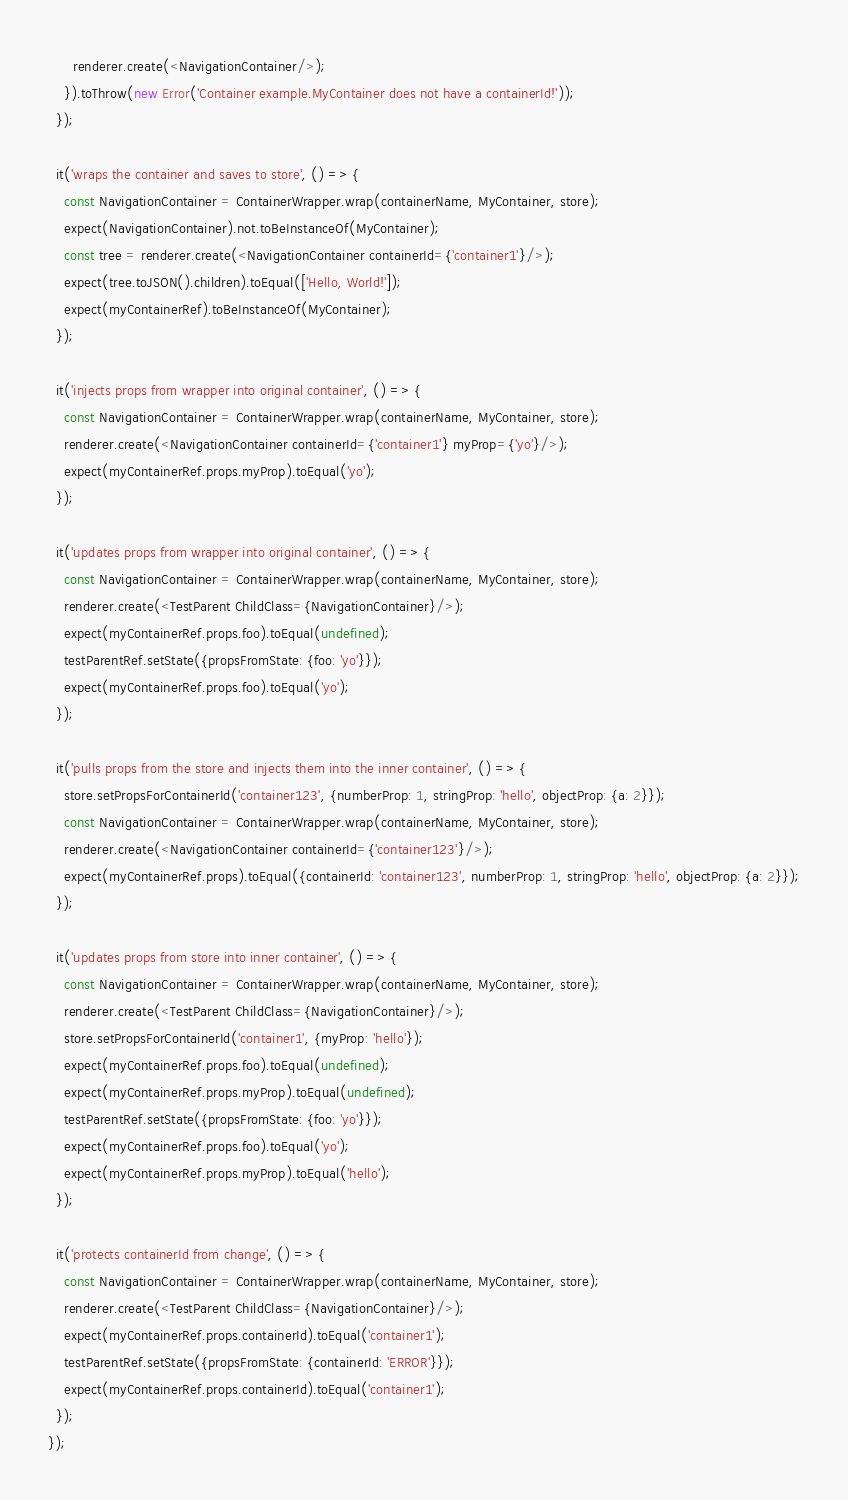<code> <loc_0><loc_0><loc_500><loc_500><_JavaScript_>      renderer.create(<NavigationContainer/>);
    }).toThrow(new Error('Container example.MyContainer does not have a containerId!'));
  });

  it('wraps the container and saves to store', () => {
    const NavigationContainer = ContainerWrapper.wrap(containerName, MyContainer, store);
    expect(NavigationContainer).not.toBeInstanceOf(MyContainer);
    const tree = renderer.create(<NavigationContainer containerId={'container1'}/>);
    expect(tree.toJSON().children).toEqual(['Hello, World!']);
    expect(myContainerRef).toBeInstanceOf(MyContainer);
  });

  it('injects props from wrapper into original container', () => {
    const NavigationContainer = ContainerWrapper.wrap(containerName, MyContainer, store);
    renderer.create(<NavigationContainer containerId={'container1'} myProp={'yo'}/>);
    expect(myContainerRef.props.myProp).toEqual('yo');
  });

  it('updates props from wrapper into original container', () => {
    const NavigationContainer = ContainerWrapper.wrap(containerName, MyContainer, store);
    renderer.create(<TestParent ChildClass={NavigationContainer}/>);
    expect(myContainerRef.props.foo).toEqual(undefined);
    testParentRef.setState({propsFromState: {foo: 'yo'}});
    expect(myContainerRef.props.foo).toEqual('yo');
  });

  it('pulls props from the store and injects them into the inner container', () => {
    store.setPropsForContainerId('container123', {numberProp: 1, stringProp: 'hello', objectProp: {a: 2}});
    const NavigationContainer = ContainerWrapper.wrap(containerName, MyContainer, store);
    renderer.create(<NavigationContainer containerId={'container123'}/>);
    expect(myContainerRef.props).toEqual({containerId: 'container123', numberProp: 1, stringProp: 'hello', objectProp: {a: 2}});
  });

  it('updates props from store into inner container', () => {
    const NavigationContainer = ContainerWrapper.wrap(containerName, MyContainer, store);
    renderer.create(<TestParent ChildClass={NavigationContainer}/>);
    store.setPropsForContainerId('container1', {myProp: 'hello'});
    expect(myContainerRef.props.foo).toEqual(undefined);
    expect(myContainerRef.props.myProp).toEqual(undefined);
    testParentRef.setState({propsFromState: {foo: 'yo'}});
    expect(myContainerRef.props.foo).toEqual('yo');
    expect(myContainerRef.props.myProp).toEqual('hello');
  });

  it('protects containerId from change', () => {
    const NavigationContainer = ContainerWrapper.wrap(containerName, MyContainer, store);
    renderer.create(<TestParent ChildClass={NavigationContainer}/>);
    expect(myContainerRef.props.containerId).toEqual('container1');
    testParentRef.setState({propsFromState: {containerId: 'ERROR'}});
    expect(myContainerRef.props.containerId).toEqual('container1');
  });
});
</code> 